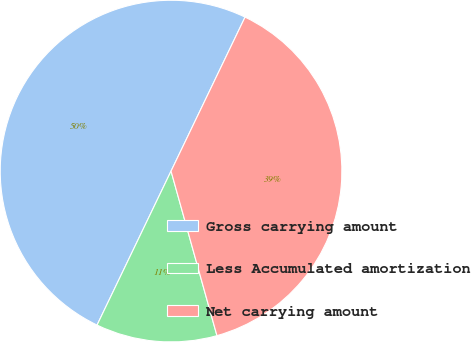Convert chart. <chart><loc_0><loc_0><loc_500><loc_500><pie_chart><fcel>Gross carrying amount<fcel>Less Accumulated amortization<fcel>Net carrying amount<nl><fcel>50.0%<fcel>11.46%<fcel>38.54%<nl></chart> 